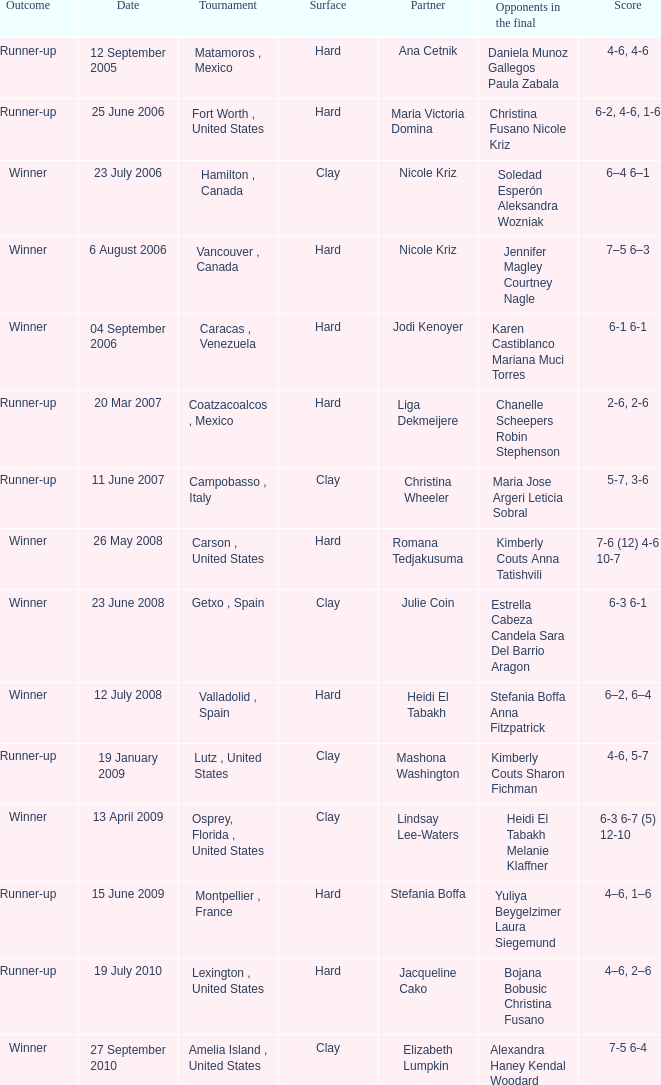Who were the opponents during the final when christina wheeler was partner? Maria Jose Argeri Leticia Sobral. 